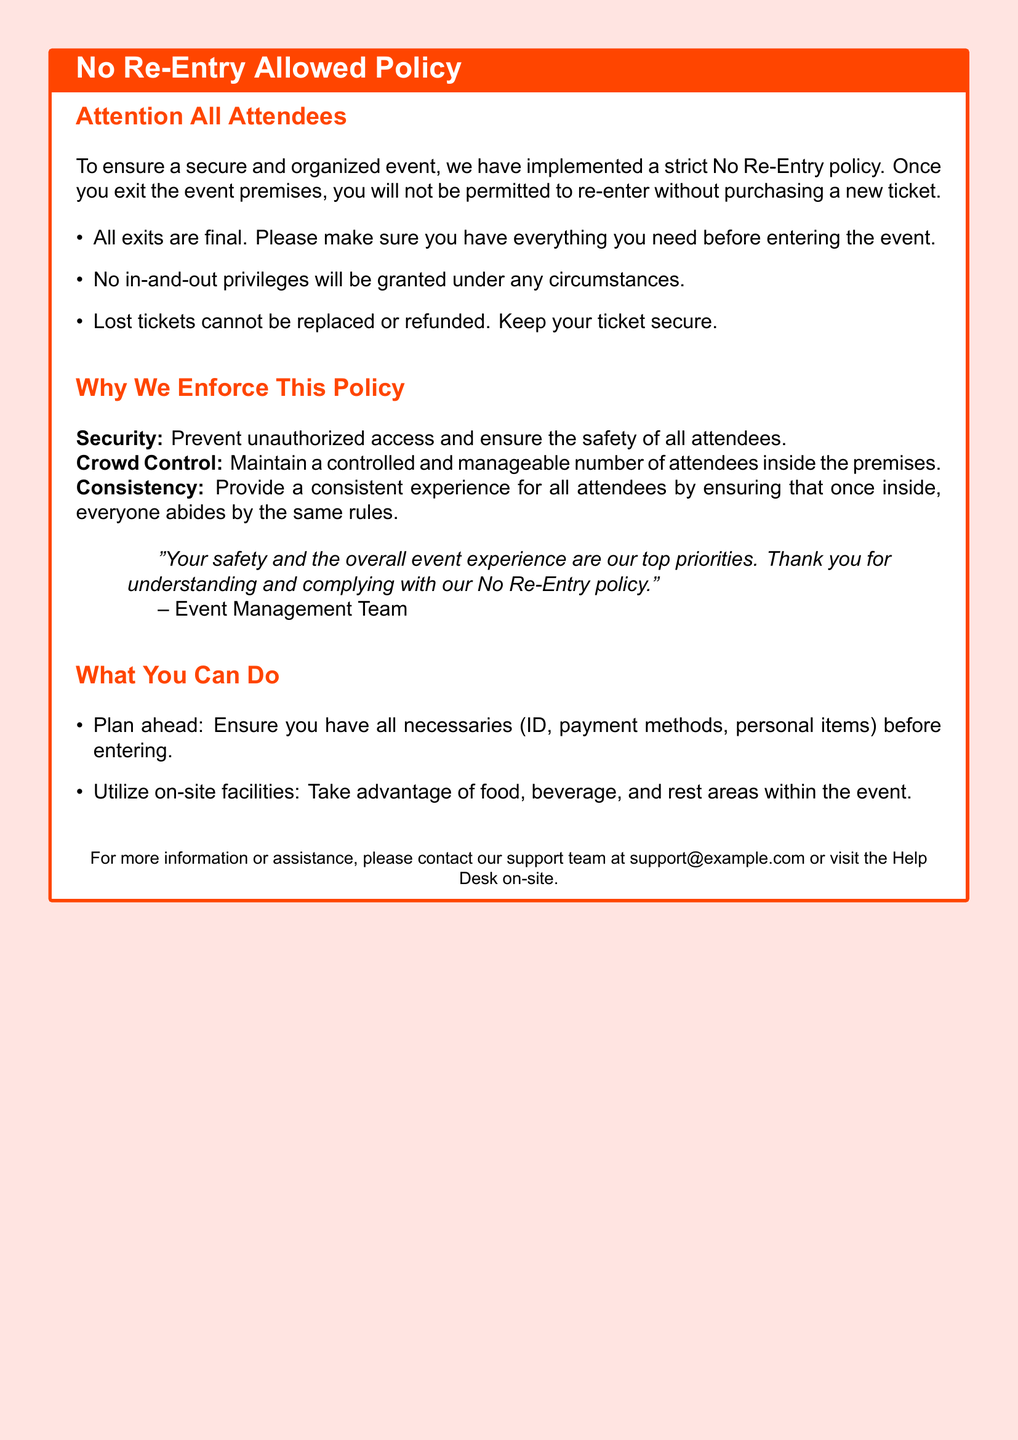What is the color of the box's frame? The document specifies the color of the box's frame as warning red.
Answer: warning red What should you do if you lose your ticket? The document states that lost tickets cannot be replaced or refunded.
Answer: Cannot be replaced What does the No Re-Entry policy prevent? The policy aims to prevent unauthorized access and ensure safety as mentioned under security.
Answer: Unauthorized access What should you ensure before entering the event? The document advises that you should make sure you have everything you need before entering.
Answer: Everything you need Who does the event management team prioritize according to the document? The document emphasizes that the safety and overall event experience are top priorities of the event management team.
Answer: Safety What action is not allowed under any circumstances? The document clearly states that no in-and-out privileges will be granted.
Answer: No in-and-out privileges What should attendees utilize during the event? The document suggests taking advantage of food, beverage, and rest areas available on-site.
Answer: On-site facilities What does the policy state about exits? It specifies that all exits are final.
Answer: All exits are final 